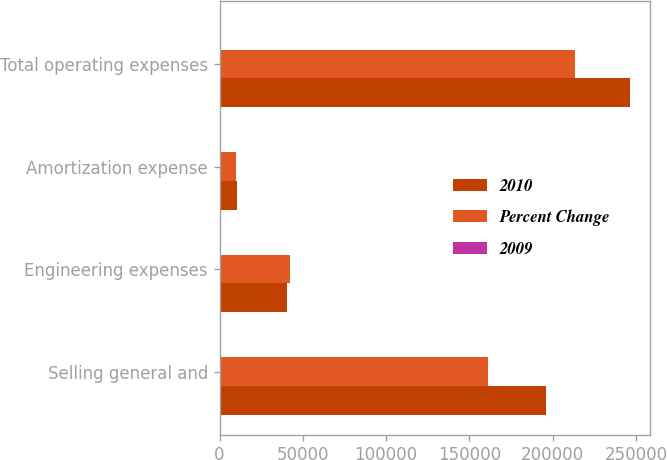Convert chart. <chart><loc_0><loc_0><loc_500><loc_500><stacked_bar_chart><ecel><fcel>Selling general and<fcel>Engineering expenses<fcel>Amortization expense<fcel>Total operating expenses<nl><fcel>2010<fcel>195892<fcel>40203<fcel>10173<fcel>246268<nl><fcel>Percent Change<fcel>160998<fcel>42447<fcel>9849<fcel>213294<nl><fcel>2009<fcel>21.7<fcel>5.3<fcel>3.3<fcel>15.5<nl></chart> 